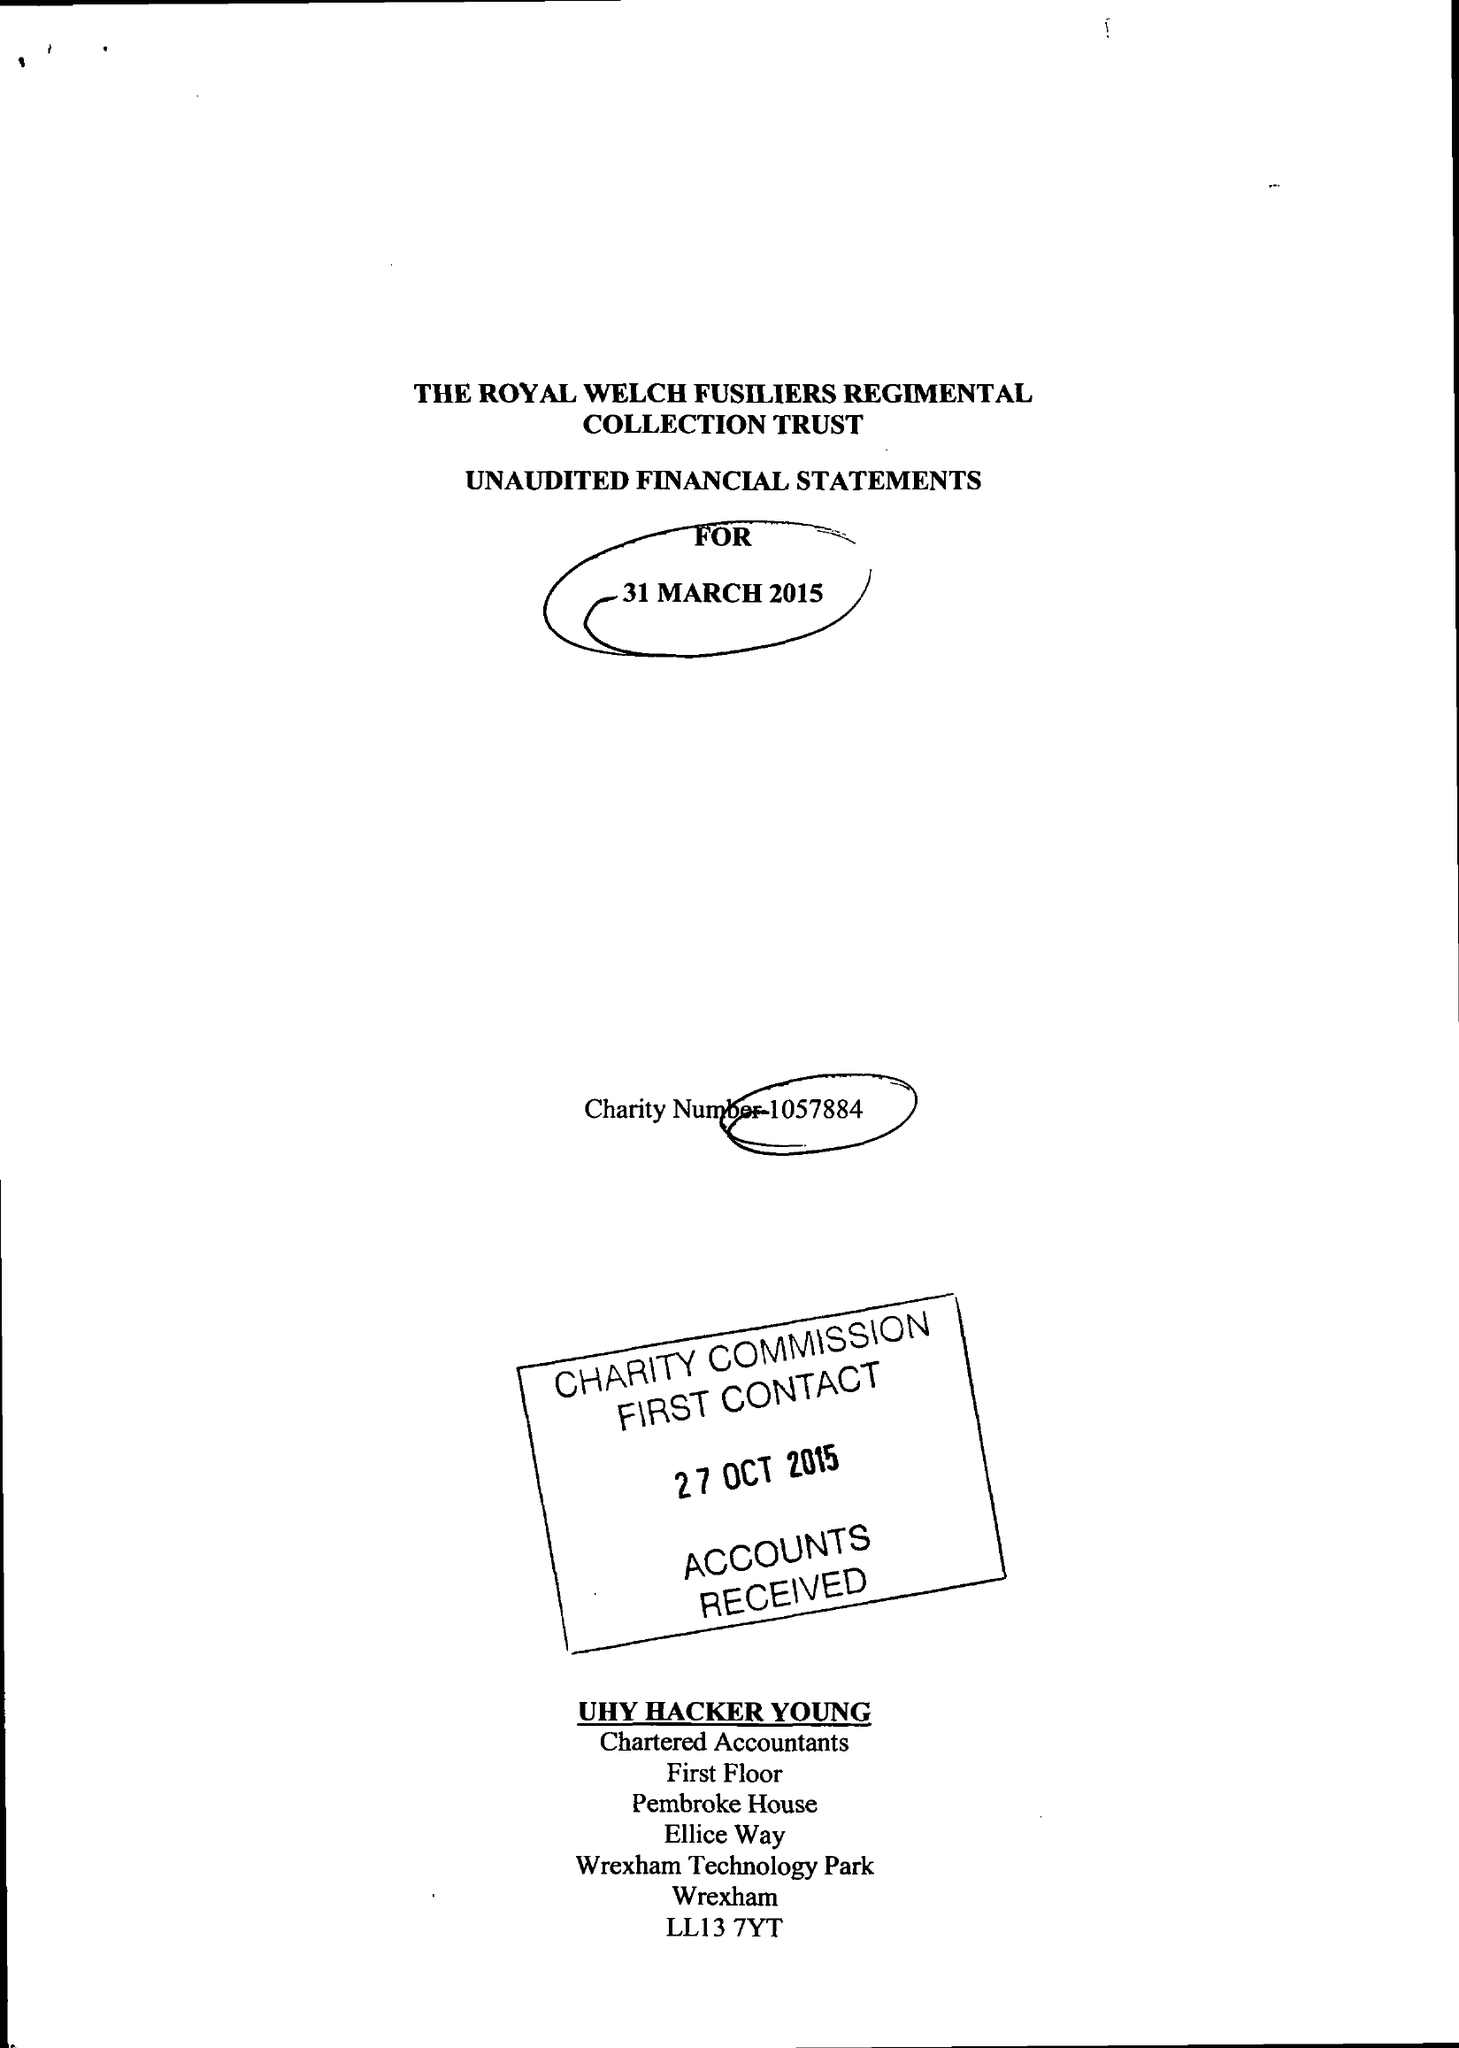What is the value for the address__post_town?
Answer the question using a single word or phrase. WREXHAM 